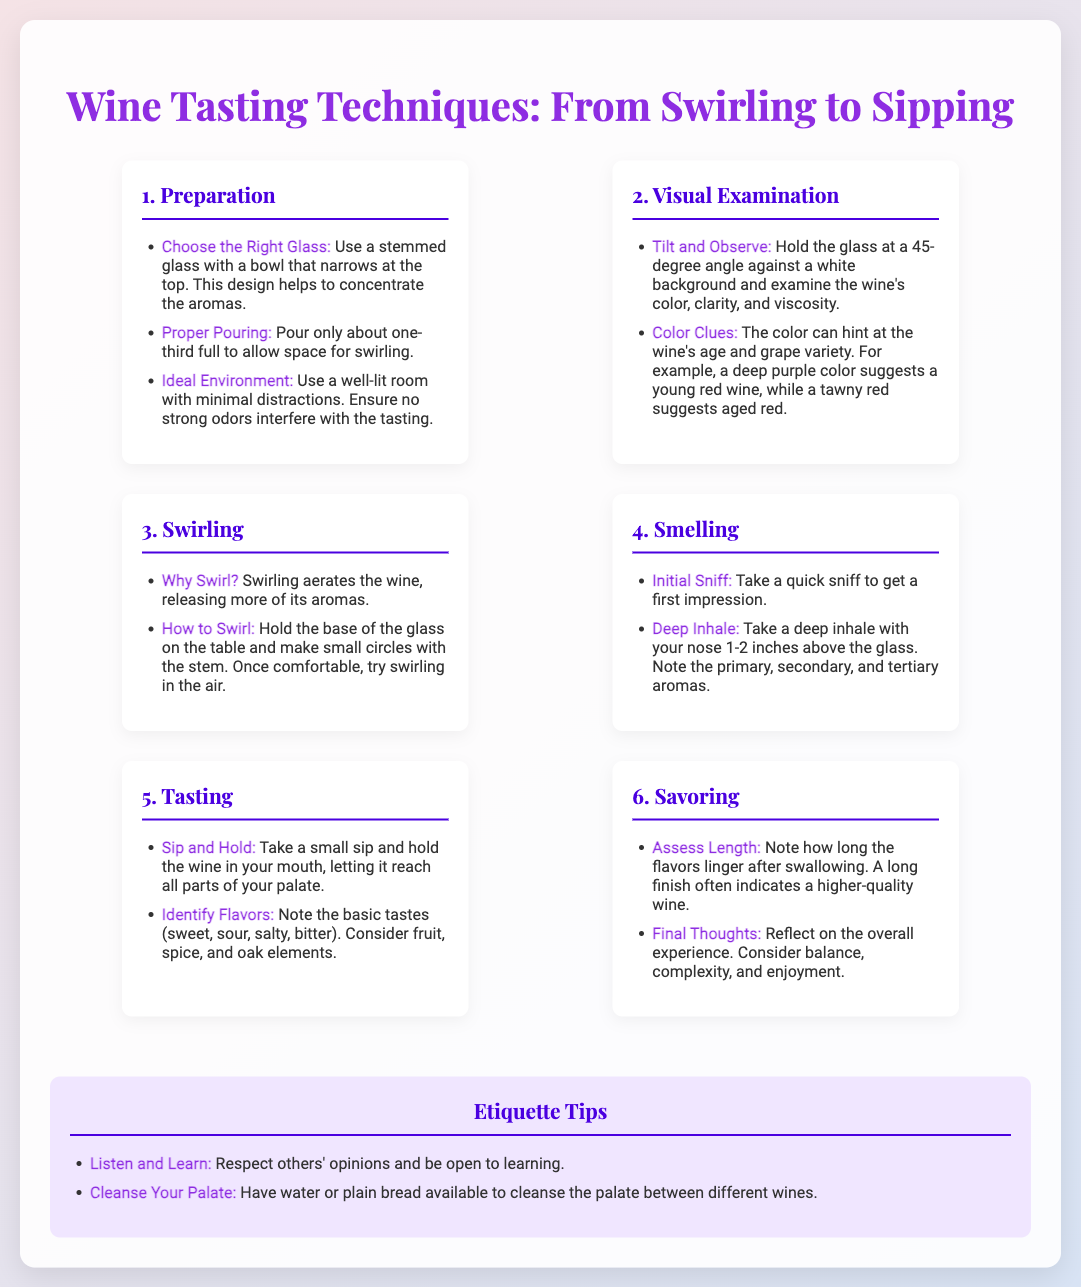What is the first step in wine tasting? The first step in wine tasting listed in the document is "Preparation."
Answer: Preparation What type of glass is recommended for wine tasting? The document specifies using a "stemmed glass with a bowl that narrows at the top."
Answer: Stemmed glass How should the wine be poured? The document states to "pour only about one-third full."
Answer: One-third full What should you do during the visual examination of the wine? You should "hold the glass at a 45-degree angle against a white background."
Answer: Tilt and observe What does swirling the wine do? Swirling aerates the wine, which "releases more of its aromas."
Answer: Releases aromas What flavor elements should be considered while tasting? The document mentions considering "fruit, spice, and oak elements."
Answer: Fruit, spice, and oak What should be assessed during savoring? You should "note how long the flavors linger after swallowing."
Answer: Length What should you have available to cleanse your palate? The document suggests to have "water or plain bread" available.
Answer: Water or plain bread What is the etiquette tip related to respecting opinions? The document encourages to "listen and learn."
Answer: Listen and learn 